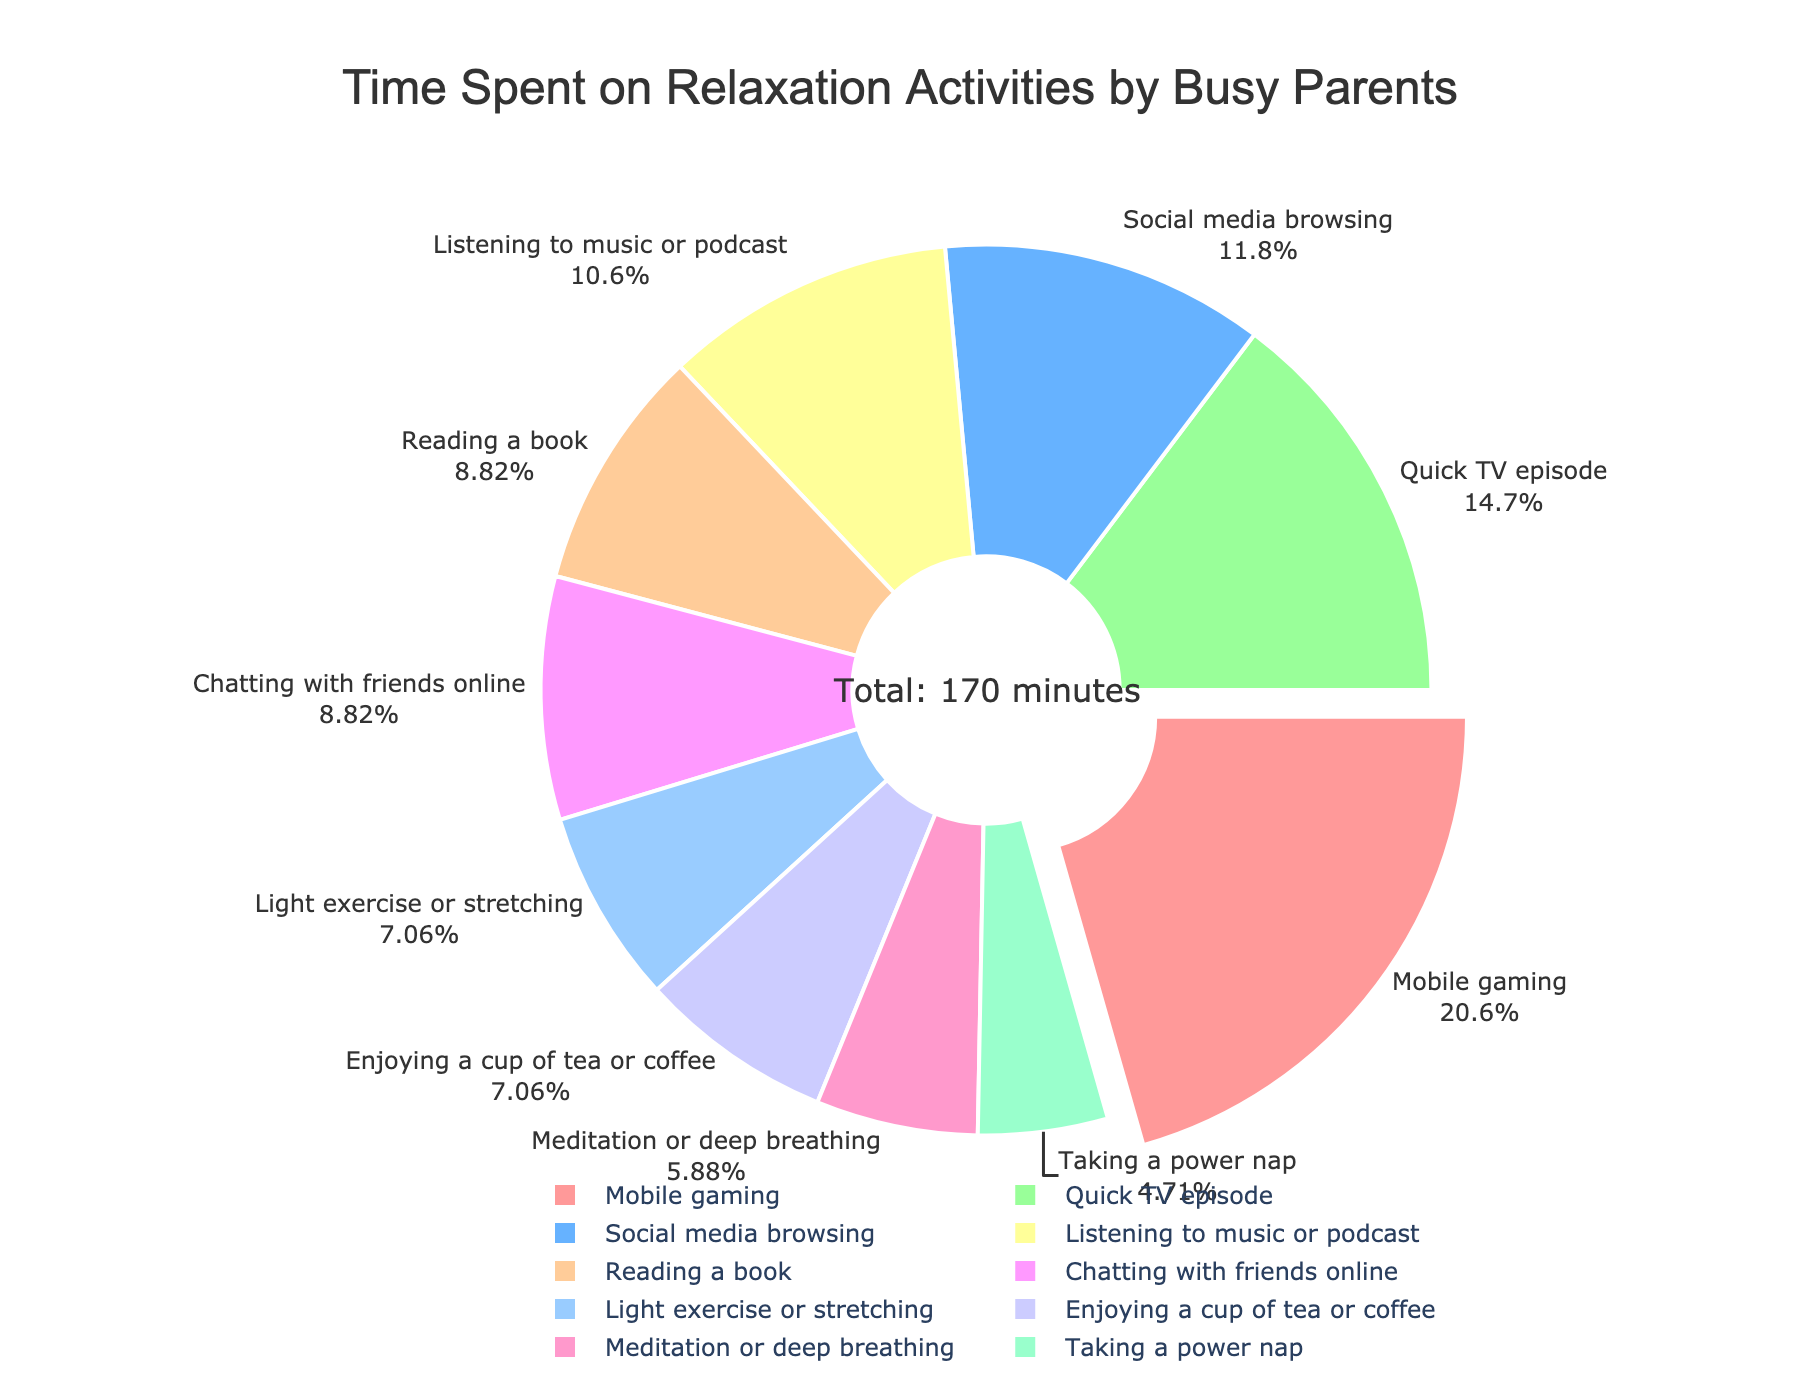What's the most time-consuming relaxation activity? The largest segment or 'slice' of the pie chart represents the activity with the highest percentage. In this case, "Mobile gaming" is visually the largest segment. It is also pulled out slightly to emphasize its volume.
Answer: Mobile gaming Which activity is the least time-consuming? The smallest segment of the pie chart represents the activity with the lowest percentage. Here, "Taking a power nap" appears to take up the least space.
Answer: Taking a power nap How much total time is spent on activities involving media (mobile gaming, social media browsing, quick TV episode, listening to music or podcast)? Sum the time spent on each relevant activity: 35 (Mobile gaming) + 20 (Social media browsing) + 25 (Quick TV episode) + 18 (Listening to music or podcast) = 98 minutes.
Answer: 98 minutes What percentage of time is spent on activities related to relaxation techniques (meditation or deep breathing and light exercise or stretching)? Sum the total minutes for "Meditation or deep breathing" and "Light exercise or stretching," then calculate the percentage relative to the total time: (10 + 12) / 170 * 100 ≈ 12.9%.
Answer: ~12.9% How does the time spent on reading a book compare to chatting with friends online? Both activities have the same number of minutes dedicated to them per day (15 minutes each), indicated by equally-sized sections in the pie chart.
Answer: Equal Which activities have the same amount of time dedicated to them? The pie chart shows that "Reading a book" and "Chatting with friends online" both take up 15 minutes of the total daily relaxation time.
Answer: Reading a book, Chatting with friends online What's the sum of time spent on 'enjoying a cup of tea or coffee' and 'light exercise or stretching'? Add the minutes spent on "Enjoying a cup of tea or coffee" (12 minutes) and "Light exercise or stretching" (12 minutes): 12 + 12 = 24 minutes.
Answer: 24 minutes Which activity is more time-consuming, 'listening to music or podcast' or 'social media browsing'? Compare the pie chart segments for "Listening to music or podcast" (18 minutes) and "Social media browsing" (20 minutes). "Social media browsing" has a slightly larger segment.
Answer: Social media browsing What activities take up more than 10% of the total relaxation time each? For this, check which segments have a percentage label greater than 10%. The following activities qualify: "Mobile gaming" (20.59%), "Quick TV episode" (14.71%).
Answer: Mobile gaming, Quick TV episode 